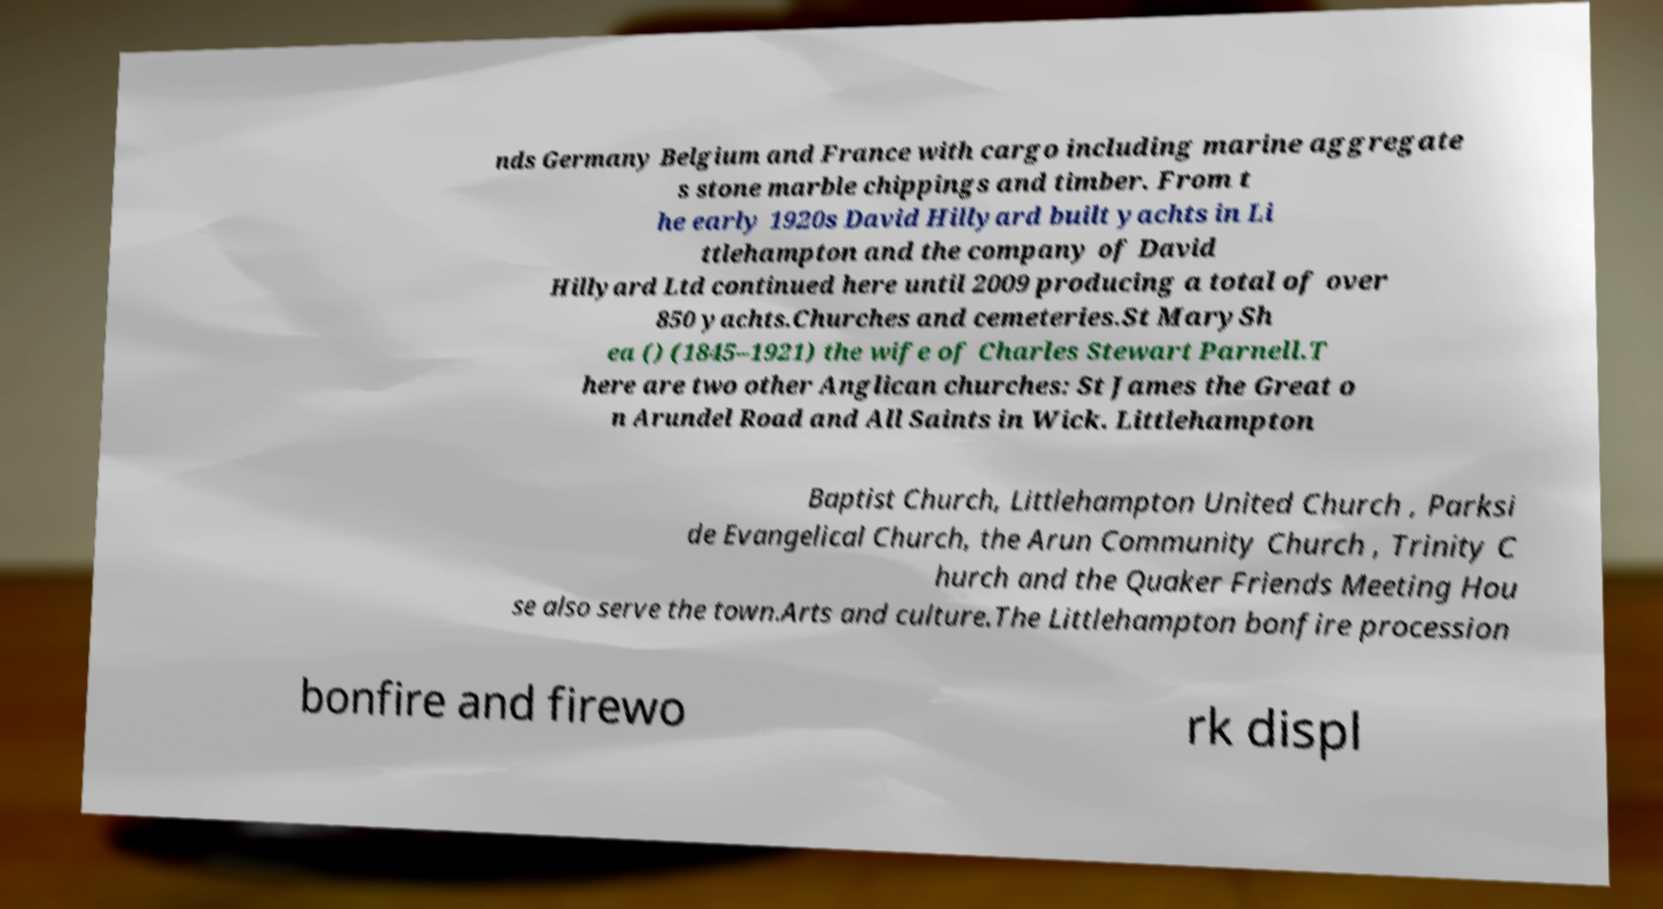Could you extract and type out the text from this image? nds Germany Belgium and France with cargo including marine aggregate s stone marble chippings and timber. From t he early 1920s David Hillyard built yachts in Li ttlehampton and the company of David Hillyard Ltd continued here until 2009 producing a total of over 850 yachts.Churches and cemeteries.St MarySh ea () (1845–1921) the wife of Charles Stewart Parnell.T here are two other Anglican churches: St James the Great o n Arundel Road and All Saints in Wick. Littlehampton Baptist Church, Littlehampton United Church , Parksi de Evangelical Church, the Arun Community Church , Trinity C hurch and the Quaker Friends Meeting Hou se also serve the town.Arts and culture.The Littlehampton bonfire procession bonfire and firewo rk displ 